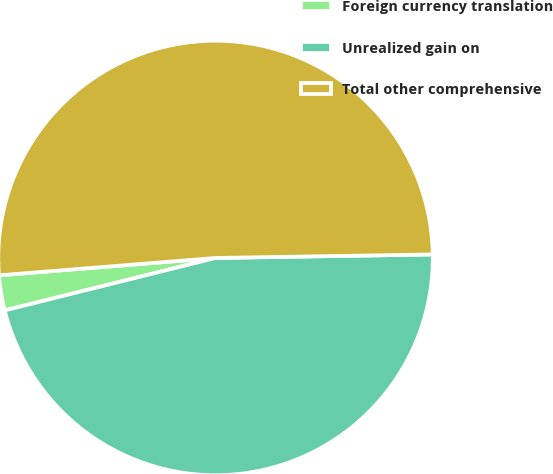Convert chart. <chart><loc_0><loc_0><loc_500><loc_500><pie_chart><fcel>Foreign currency translation<fcel>Unrealized gain on<fcel>Total other comprehensive<nl><fcel>2.61%<fcel>46.38%<fcel>51.02%<nl></chart> 